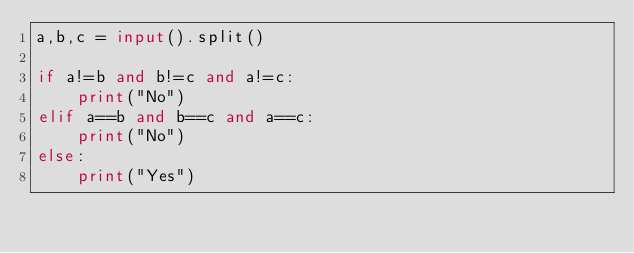Convert code to text. <code><loc_0><loc_0><loc_500><loc_500><_Python_>a,b,c = input().split()

if a!=b and b!=c and a!=c:
    print("No")
elif a==b and b==c and a==c:
    print("No")
else:
    print("Yes")</code> 